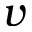Convert formula to latex. <formula><loc_0><loc_0><loc_500><loc_500>v</formula> 